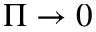Convert formula to latex. <formula><loc_0><loc_0><loc_500><loc_500>\Pi \to 0</formula> 